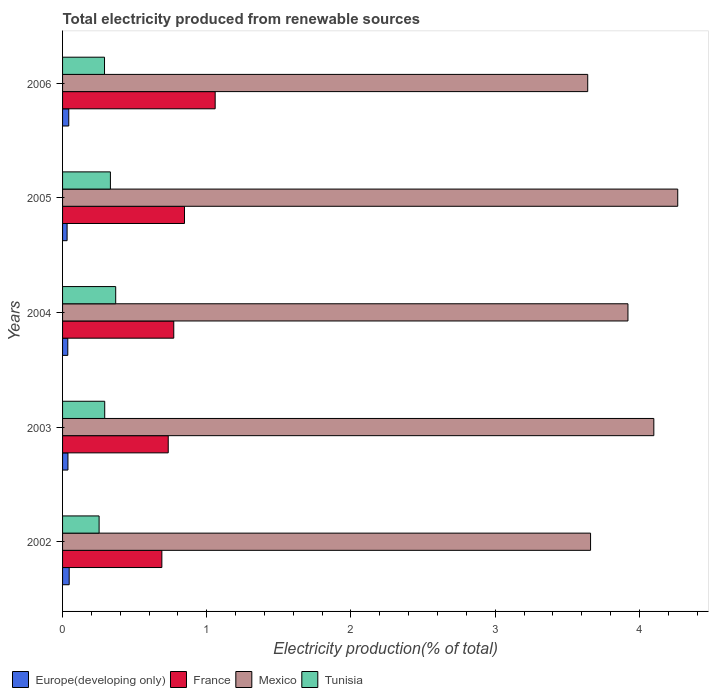What is the label of the 5th group of bars from the top?
Offer a terse response. 2002. What is the total electricity produced in Tunisia in 2002?
Offer a very short reply. 0.25. Across all years, what is the maximum total electricity produced in Europe(developing only)?
Your response must be concise. 0.05. Across all years, what is the minimum total electricity produced in France?
Make the answer very short. 0.69. In which year was the total electricity produced in Tunisia maximum?
Give a very brief answer. 2004. What is the total total electricity produced in France in the graph?
Offer a terse response. 4.1. What is the difference between the total electricity produced in France in 2004 and that in 2005?
Provide a succinct answer. -0.07. What is the difference between the total electricity produced in France in 2006 and the total electricity produced in Mexico in 2005?
Provide a succinct answer. -3.21. What is the average total electricity produced in Mexico per year?
Ensure brevity in your answer.  3.92. In the year 2003, what is the difference between the total electricity produced in Tunisia and total electricity produced in France?
Give a very brief answer. -0.44. What is the ratio of the total electricity produced in Tunisia in 2003 to that in 2004?
Offer a very short reply. 0.79. Is the total electricity produced in Tunisia in 2002 less than that in 2004?
Offer a terse response. Yes. What is the difference between the highest and the second highest total electricity produced in Mexico?
Provide a short and direct response. 0.17. What is the difference between the highest and the lowest total electricity produced in Tunisia?
Provide a succinct answer. 0.12. Is it the case that in every year, the sum of the total electricity produced in Mexico and total electricity produced in France is greater than the sum of total electricity produced in Europe(developing only) and total electricity produced in Tunisia?
Your answer should be compact. Yes. Is it the case that in every year, the sum of the total electricity produced in Tunisia and total electricity produced in Europe(developing only) is greater than the total electricity produced in Mexico?
Give a very brief answer. No. How many bars are there?
Provide a short and direct response. 20. How many years are there in the graph?
Keep it short and to the point. 5. Does the graph contain any zero values?
Provide a succinct answer. No. Where does the legend appear in the graph?
Make the answer very short. Bottom left. How are the legend labels stacked?
Provide a short and direct response. Horizontal. What is the title of the graph?
Your answer should be compact. Total electricity produced from renewable sources. What is the Electricity production(% of total) of Europe(developing only) in 2002?
Offer a terse response. 0.05. What is the Electricity production(% of total) in France in 2002?
Your response must be concise. 0.69. What is the Electricity production(% of total) of Mexico in 2002?
Give a very brief answer. 3.66. What is the Electricity production(% of total) in Tunisia in 2002?
Offer a terse response. 0.25. What is the Electricity production(% of total) of Europe(developing only) in 2003?
Ensure brevity in your answer.  0.04. What is the Electricity production(% of total) of France in 2003?
Provide a short and direct response. 0.73. What is the Electricity production(% of total) in Mexico in 2003?
Offer a very short reply. 4.1. What is the Electricity production(% of total) in Tunisia in 2003?
Offer a terse response. 0.29. What is the Electricity production(% of total) of Europe(developing only) in 2004?
Make the answer very short. 0.04. What is the Electricity production(% of total) in France in 2004?
Provide a short and direct response. 0.77. What is the Electricity production(% of total) of Mexico in 2004?
Your answer should be compact. 3.92. What is the Electricity production(% of total) in Tunisia in 2004?
Ensure brevity in your answer.  0.37. What is the Electricity production(% of total) of Europe(developing only) in 2005?
Offer a very short reply. 0.03. What is the Electricity production(% of total) in France in 2005?
Keep it short and to the point. 0.85. What is the Electricity production(% of total) of Mexico in 2005?
Provide a succinct answer. 4.27. What is the Electricity production(% of total) of Tunisia in 2005?
Give a very brief answer. 0.33. What is the Electricity production(% of total) in Europe(developing only) in 2006?
Provide a short and direct response. 0.04. What is the Electricity production(% of total) in France in 2006?
Your response must be concise. 1.06. What is the Electricity production(% of total) in Mexico in 2006?
Make the answer very short. 3.64. What is the Electricity production(% of total) of Tunisia in 2006?
Your answer should be very brief. 0.29. Across all years, what is the maximum Electricity production(% of total) in Europe(developing only)?
Your answer should be very brief. 0.05. Across all years, what is the maximum Electricity production(% of total) of France?
Offer a very short reply. 1.06. Across all years, what is the maximum Electricity production(% of total) in Mexico?
Provide a succinct answer. 4.27. Across all years, what is the maximum Electricity production(% of total) of Tunisia?
Give a very brief answer. 0.37. Across all years, what is the minimum Electricity production(% of total) of Europe(developing only)?
Offer a very short reply. 0.03. Across all years, what is the minimum Electricity production(% of total) in France?
Give a very brief answer. 0.69. Across all years, what is the minimum Electricity production(% of total) of Mexico?
Ensure brevity in your answer.  3.64. Across all years, what is the minimum Electricity production(% of total) in Tunisia?
Your response must be concise. 0.25. What is the total Electricity production(% of total) in Europe(developing only) in the graph?
Give a very brief answer. 0.19. What is the total Electricity production(% of total) in France in the graph?
Your answer should be very brief. 4.1. What is the total Electricity production(% of total) of Mexico in the graph?
Your answer should be very brief. 19.59. What is the total Electricity production(% of total) in Tunisia in the graph?
Make the answer very short. 1.54. What is the difference between the Electricity production(% of total) in Europe(developing only) in 2002 and that in 2003?
Offer a terse response. 0.01. What is the difference between the Electricity production(% of total) of France in 2002 and that in 2003?
Ensure brevity in your answer.  -0.04. What is the difference between the Electricity production(% of total) in Mexico in 2002 and that in 2003?
Provide a short and direct response. -0.44. What is the difference between the Electricity production(% of total) of Tunisia in 2002 and that in 2003?
Give a very brief answer. -0.04. What is the difference between the Electricity production(% of total) in Europe(developing only) in 2002 and that in 2004?
Your answer should be compact. 0.01. What is the difference between the Electricity production(% of total) of France in 2002 and that in 2004?
Provide a short and direct response. -0.08. What is the difference between the Electricity production(% of total) in Mexico in 2002 and that in 2004?
Your answer should be very brief. -0.26. What is the difference between the Electricity production(% of total) of Tunisia in 2002 and that in 2004?
Provide a succinct answer. -0.12. What is the difference between the Electricity production(% of total) of Europe(developing only) in 2002 and that in 2005?
Your answer should be compact. 0.01. What is the difference between the Electricity production(% of total) of France in 2002 and that in 2005?
Your answer should be compact. -0.16. What is the difference between the Electricity production(% of total) of Mexico in 2002 and that in 2005?
Provide a short and direct response. -0.6. What is the difference between the Electricity production(% of total) in Tunisia in 2002 and that in 2005?
Make the answer very short. -0.08. What is the difference between the Electricity production(% of total) of Europe(developing only) in 2002 and that in 2006?
Offer a terse response. 0. What is the difference between the Electricity production(% of total) of France in 2002 and that in 2006?
Offer a terse response. -0.37. What is the difference between the Electricity production(% of total) of Mexico in 2002 and that in 2006?
Make the answer very short. 0.02. What is the difference between the Electricity production(% of total) of Tunisia in 2002 and that in 2006?
Provide a short and direct response. -0.04. What is the difference between the Electricity production(% of total) of Europe(developing only) in 2003 and that in 2004?
Offer a very short reply. 0. What is the difference between the Electricity production(% of total) of France in 2003 and that in 2004?
Give a very brief answer. -0.04. What is the difference between the Electricity production(% of total) in Mexico in 2003 and that in 2004?
Offer a terse response. 0.18. What is the difference between the Electricity production(% of total) of Tunisia in 2003 and that in 2004?
Give a very brief answer. -0.08. What is the difference between the Electricity production(% of total) of Europe(developing only) in 2003 and that in 2005?
Offer a terse response. 0.01. What is the difference between the Electricity production(% of total) of France in 2003 and that in 2005?
Make the answer very short. -0.11. What is the difference between the Electricity production(% of total) in Mexico in 2003 and that in 2005?
Offer a terse response. -0.17. What is the difference between the Electricity production(% of total) in Tunisia in 2003 and that in 2005?
Provide a succinct answer. -0.04. What is the difference between the Electricity production(% of total) of Europe(developing only) in 2003 and that in 2006?
Provide a succinct answer. -0.01. What is the difference between the Electricity production(% of total) in France in 2003 and that in 2006?
Ensure brevity in your answer.  -0.33. What is the difference between the Electricity production(% of total) of Mexico in 2003 and that in 2006?
Your response must be concise. 0.46. What is the difference between the Electricity production(% of total) of Tunisia in 2003 and that in 2006?
Offer a very short reply. 0. What is the difference between the Electricity production(% of total) of Europe(developing only) in 2004 and that in 2005?
Your answer should be compact. 0. What is the difference between the Electricity production(% of total) in France in 2004 and that in 2005?
Keep it short and to the point. -0.07. What is the difference between the Electricity production(% of total) in Mexico in 2004 and that in 2005?
Provide a succinct answer. -0.35. What is the difference between the Electricity production(% of total) of Tunisia in 2004 and that in 2005?
Provide a short and direct response. 0.04. What is the difference between the Electricity production(% of total) in Europe(developing only) in 2004 and that in 2006?
Provide a short and direct response. -0.01. What is the difference between the Electricity production(% of total) of France in 2004 and that in 2006?
Give a very brief answer. -0.29. What is the difference between the Electricity production(% of total) in Mexico in 2004 and that in 2006?
Keep it short and to the point. 0.28. What is the difference between the Electricity production(% of total) in Tunisia in 2004 and that in 2006?
Offer a very short reply. 0.08. What is the difference between the Electricity production(% of total) in Europe(developing only) in 2005 and that in 2006?
Keep it short and to the point. -0.01. What is the difference between the Electricity production(% of total) of France in 2005 and that in 2006?
Your response must be concise. -0.21. What is the difference between the Electricity production(% of total) of Mexico in 2005 and that in 2006?
Provide a succinct answer. 0.62. What is the difference between the Electricity production(% of total) in Tunisia in 2005 and that in 2006?
Your response must be concise. 0.04. What is the difference between the Electricity production(% of total) of Europe(developing only) in 2002 and the Electricity production(% of total) of France in 2003?
Offer a terse response. -0.69. What is the difference between the Electricity production(% of total) in Europe(developing only) in 2002 and the Electricity production(% of total) in Mexico in 2003?
Your answer should be very brief. -4.05. What is the difference between the Electricity production(% of total) of Europe(developing only) in 2002 and the Electricity production(% of total) of Tunisia in 2003?
Offer a very short reply. -0.25. What is the difference between the Electricity production(% of total) in France in 2002 and the Electricity production(% of total) in Mexico in 2003?
Keep it short and to the point. -3.41. What is the difference between the Electricity production(% of total) in France in 2002 and the Electricity production(% of total) in Tunisia in 2003?
Your answer should be compact. 0.4. What is the difference between the Electricity production(% of total) of Mexico in 2002 and the Electricity production(% of total) of Tunisia in 2003?
Keep it short and to the point. 3.37. What is the difference between the Electricity production(% of total) in Europe(developing only) in 2002 and the Electricity production(% of total) in France in 2004?
Your answer should be compact. -0.73. What is the difference between the Electricity production(% of total) of Europe(developing only) in 2002 and the Electricity production(% of total) of Mexico in 2004?
Ensure brevity in your answer.  -3.87. What is the difference between the Electricity production(% of total) of Europe(developing only) in 2002 and the Electricity production(% of total) of Tunisia in 2004?
Keep it short and to the point. -0.32. What is the difference between the Electricity production(% of total) of France in 2002 and the Electricity production(% of total) of Mexico in 2004?
Make the answer very short. -3.23. What is the difference between the Electricity production(% of total) in France in 2002 and the Electricity production(% of total) in Tunisia in 2004?
Give a very brief answer. 0.32. What is the difference between the Electricity production(% of total) of Mexico in 2002 and the Electricity production(% of total) of Tunisia in 2004?
Provide a succinct answer. 3.29. What is the difference between the Electricity production(% of total) of Europe(developing only) in 2002 and the Electricity production(% of total) of France in 2005?
Your answer should be compact. -0.8. What is the difference between the Electricity production(% of total) of Europe(developing only) in 2002 and the Electricity production(% of total) of Mexico in 2005?
Offer a terse response. -4.22. What is the difference between the Electricity production(% of total) of Europe(developing only) in 2002 and the Electricity production(% of total) of Tunisia in 2005?
Your answer should be very brief. -0.29. What is the difference between the Electricity production(% of total) in France in 2002 and the Electricity production(% of total) in Mexico in 2005?
Provide a succinct answer. -3.58. What is the difference between the Electricity production(% of total) of France in 2002 and the Electricity production(% of total) of Tunisia in 2005?
Offer a very short reply. 0.36. What is the difference between the Electricity production(% of total) in Mexico in 2002 and the Electricity production(% of total) in Tunisia in 2005?
Provide a short and direct response. 3.33. What is the difference between the Electricity production(% of total) in Europe(developing only) in 2002 and the Electricity production(% of total) in France in 2006?
Provide a short and direct response. -1.01. What is the difference between the Electricity production(% of total) of Europe(developing only) in 2002 and the Electricity production(% of total) of Mexico in 2006?
Provide a succinct answer. -3.6. What is the difference between the Electricity production(% of total) in Europe(developing only) in 2002 and the Electricity production(% of total) in Tunisia in 2006?
Give a very brief answer. -0.24. What is the difference between the Electricity production(% of total) in France in 2002 and the Electricity production(% of total) in Mexico in 2006?
Your answer should be compact. -2.95. What is the difference between the Electricity production(% of total) of France in 2002 and the Electricity production(% of total) of Tunisia in 2006?
Your answer should be compact. 0.4. What is the difference between the Electricity production(% of total) of Mexico in 2002 and the Electricity production(% of total) of Tunisia in 2006?
Provide a short and direct response. 3.37. What is the difference between the Electricity production(% of total) of Europe(developing only) in 2003 and the Electricity production(% of total) of France in 2004?
Ensure brevity in your answer.  -0.73. What is the difference between the Electricity production(% of total) in Europe(developing only) in 2003 and the Electricity production(% of total) in Mexico in 2004?
Offer a terse response. -3.88. What is the difference between the Electricity production(% of total) of Europe(developing only) in 2003 and the Electricity production(% of total) of Tunisia in 2004?
Offer a very short reply. -0.33. What is the difference between the Electricity production(% of total) of France in 2003 and the Electricity production(% of total) of Mexico in 2004?
Your answer should be compact. -3.19. What is the difference between the Electricity production(% of total) of France in 2003 and the Electricity production(% of total) of Tunisia in 2004?
Give a very brief answer. 0.36. What is the difference between the Electricity production(% of total) in Mexico in 2003 and the Electricity production(% of total) in Tunisia in 2004?
Provide a short and direct response. 3.73. What is the difference between the Electricity production(% of total) in Europe(developing only) in 2003 and the Electricity production(% of total) in France in 2005?
Keep it short and to the point. -0.81. What is the difference between the Electricity production(% of total) of Europe(developing only) in 2003 and the Electricity production(% of total) of Mexico in 2005?
Ensure brevity in your answer.  -4.23. What is the difference between the Electricity production(% of total) of Europe(developing only) in 2003 and the Electricity production(% of total) of Tunisia in 2005?
Keep it short and to the point. -0.29. What is the difference between the Electricity production(% of total) of France in 2003 and the Electricity production(% of total) of Mexico in 2005?
Your answer should be very brief. -3.53. What is the difference between the Electricity production(% of total) in France in 2003 and the Electricity production(% of total) in Tunisia in 2005?
Provide a short and direct response. 0.4. What is the difference between the Electricity production(% of total) in Mexico in 2003 and the Electricity production(% of total) in Tunisia in 2005?
Provide a short and direct response. 3.77. What is the difference between the Electricity production(% of total) of Europe(developing only) in 2003 and the Electricity production(% of total) of France in 2006?
Make the answer very short. -1.02. What is the difference between the Electricity production(% of total) in Europe(developing only) in 2003 and the Electricity production(% of total) in Mexico in 2006?
Offer a terse response. -3.6. What is the difference between the Electricity production(% of total) of Europe(developing only) in 2003 and the Electricity production(% of total) of Tunisia in 2006?
Keep it short and to the point. -0.25. What is the difference between the Electricity production(% of total) of France in 2003 and the Electricity production(% of total) of Mexico in 2006?
Offer a very short reply. -2.91. What is the difference between the Electricity production(% of total) in France in 2003 and the Electricity production(% of total) in Tunisia in 2006?
Give a very brief answer. 0.44. What is the difference between the Electricity production(% of total) in Mexico in 2003 and the Electricity production(% of total) in Tunisia in 2006?
Offer a terse response. 3.81. What is the difference between the Electricity production(% of total) of Europe(developing only) in 2004 and the Electricity production(% of total) of France in 2005?
Your answer should be very brief. -0.81. What is the difference between the Electricity production(% of total) of Europe(developing only) in 2004 and the Electricity production(% of total) of Mexico in 2005?
Ensure brevity in your answer.  -4.23. What is the difference between the Electricity production(% of total) of Europe(developing only) in 2004 and the Electricity production(% of total) of Tunisia in 2005?
Your response must be concise. -0.3. What is the difference between the Electricity production(% of total) of France in 2004 and the Electricity production(% of total) of Mexico in 2005?
Keep it short and to the point. -3.49. What is the difference between the Electricity production(% of total) of France in 2004 and the Electricity production(% of total) of Tunisia in 2005?
Provide a short and direct response. 0.44. What is the difference between the Electricity production(% of total) in Mexico in 2004 and the Electricity production(% of total) in Tunisia in 2005?
Provide a succinct answer. 3.59. What is the difference between the Electricity production(% of total) of Europe(developing only) in 2004 and the Electricity production(% of total) of France in 2006?
Give a very brief answer. -1.02. What is the difference between the Electricity production(% of total) of Europe(developing only) in 2004 and the Electricity production(% of total) of Mexico in 2006?
Ensure brevity in your answer.  -3.61. What is the difference between the Electricity production(% of total) in Europe(developing only) in 2004 and the Electricity production(% of total) in Tunisia in 2006?
Offer a terse response. -0.25. What is the difference between the Electricity production(% of total) in France in 2004 and the Electricity production(% of total) in Mexico in 2006?
Make the answer very short. -2.87. What is the difference between the Electricity production(% of total) in France in 2004 and the Electricity production(% of total) in Tunisia in 2006?
Provide a succinct answer. 0.48. What is the difference between the Electricity production(% of total) in Mexico in 2004 and the Electricity production(% of total) in Tunisia in 2006?
Your answer should be compact. 3.63. What is the difference between the Electricity production(% of total) in Europe(developing only) in 2005 and the Electricity production(% of total) in France in 2006?
Make the answer very short. -1.03. What is the difference between the Electricity production(% of total) of Europe(developing only) in 2005 and the Electricity production(% of total) of Mexico in 2006?
Ensure brevity in your answer.  -3.61. What is the difference between the Electricity production(% of total) of Europe(developing only) in 2005 and the Electricity production(% of total) of Tunisia in 2006?
Provide a succinct answer. -0.26. What is the difference between the Electricity production(% of total) in France in 2005 and the Electricity production(% of total) in Mexico in 2006?
Your response must be concise. -2.8. What is the difference between the Electricity production(% of total) in France in 2005 and the Electricity production(% of total) in Tunisia in 2006?
Provide a short and direct response. 0.55. What is the difference between the Electricity production(% of total) of Mexico in 2005 and the Electricity production(% of total) of Tunisia in 2006?
Your response must be concise. 3.97. What is the average Electricity production(% of total) in Europe(developing only) per year?
Make the answer very short. 0.04. What is the average Electricity production(% of total) in France per year?
Provide a short and direct response. 0.82. What is the average Electricity production(% of total) of Mexico per year?
Your response must be concise. 3.92. What is the average Electricity production(% of total) in Tunisia per year?
Make the answer very short. 0.31. In the year 2002, what is the difference between the Electricity production(% of total) of Europe(developing only) and Electricity production(% of total) of France?
Give a very brief answer. -0.64. In the year 2002, what is the difference between the Electricity production(% of total) of Europe(developing only) and Electricity production(% of total) of Mexico?
Provide a short and direct response. -3.62. In the year 2002, what is the difference between the Electricity production(% of total) in Europe(developing only) and Electricity production(% of total) in Tunisia?
Your answer should be very brief. -0.21. In the year 2002, what is the difference between the Electricity production(% of total) in France and Electricity production(% of total) in Mexico?
Offer a very short reply. -2.97. In the year 2002, what is the difference between the Electricity production(% of total) in France and Electricity production(% of total) in Tunisia?
Make the answer very short. 0.44. In the year 2002, what is the difference between the Electricity production(% of total) of Mexico and Electricity production(% of total) of Tunisia?
Offer a very short reply. 3.41. In the year 2003, what is the difference between the Electricity production(% of total) in Europe(developing only) and Electricity production(% of total) in France?
Your answer should be compact. -0.7. In the year 2003, what is the difference between the Electricity production(% of total) of Europe(developing only) and Electricity production(% of total) of Mexico?
Keep it short and to the point. -4.06. In the year 2003, what is the difference between the Electricity production(% of total) of Europe(developing only) and Electricity production(% of total) of Tunisia?
Offer a very short reply. -0.25. In the year 2003, what is the difference between the Electricity production(% of total) in France and Electricity production(% of total) in Mexico?
Provide a succinct answer. -3.37. In the year 2003, what is the difference between the Electricity production(% of total) in France and Electricity production(% of total) in Tunisia?
Ensure brevity in your answer.  0.44. In the year 2003, what is the difference between the Electricity production(% of total) of Mexico and Electricity production(% of total) of Tunisia?
Your response must be concise. 3.81. In the year 2004, what is the difference between the Electricity production(% of total) in Europe(developing only) and Electricity production(% of total) in France?
Offer a terse response. -0.73. In the year 2004, what is the difference between the Electricity production(% of total) of Europe(developing only) and Electricity production(% of total) of Mexico?
Give a very brief answer. -3.88. In the year 2004, what is the difference between the Electricity production(% of total) in Europe(developing only) and Electricity production(% of total) in Tunisia?
Your response must be concise. -0.33. In the year 2004, what is the difference between the Electricity production(% of total) of France and Electricity production(% of total) of Mexico?
Your answer should be compact. -3.15. In the year 2004, what is the difference between the Electricity production(% of total) in France and Electricity production(% of total) in Tunisia?
Your answer should be compact. 0.4. In the year 2004, what is the difference between the Electricity production(% of total) in Mexico and Electricity production(% of total) in Tunisia?
Give a very brief answer. 3.55. In the year 2005, what is the difference between the Electricity production(% of total) in Europe(developing only) and Electricity production(% of total) in France?
Provide a short and direct response. -0.81. In the year 2005, what is the difference between the Electricity production(% of total) in Europe(developing only) and Electricity production(% of total) in Mexico?
Your answer should be very brief. -4.23. In the year 2005, what is the difference between the Electricity production(% of total) in Europe(developing only) and Electricity production(% of total) in Tunisia?
Give a very brief answer. -0.3. In the year 2005, what is the difference between the Electricity production(% of total) in France and Electricity production(% of total) in Mexico?
Provide a succinct answer. -3.42. In the year 2005, what is the difference between the Electricity production(% of total) in France and Electricity production(% of total) in Tunisia?
Provide a short and direct response. 0.51. In the year 2005, what is the difference between the Electricity production(% of total) of Mexico and Electricity production(% of total) of Tunisia?
Make the answer very short. 3.93. In the year 2006, what is the difference between the Electricity production(% of total) in Europe(developing only) and Electricity production(% of total) in France?
Ensure brevity in your answer.  -1.02. In the year 2006, what is the difference between the Electricity production(% of total) in Europe(developing only) and Electricity production(% of total) in Mexico?
Your response must be concise. -3.6. In the year 2006, what is the difference between the Electricity production(% of total) of Europe(developing only) and Electricity production(% of total) of Tunisia?
Provide a succinct answer. -0.25. In the year 2006, what is the difference between the Electricity production(% of total) of France and Electricity production(% of total) of Mexico?
Your response must be concise. -2.58. In the year 2006, what is the difference between the Electricity production(% of total) of France and Electricity production(% of total) of Tunisia?
Keep it short and to the point. 0.77. In the year 2006, what is the difference between the Electricity production(% of total) in Mexico and Electricity production(% of total) in Tunisia?
Offer a very short reply. 3.35. What is the ratio of the Electricity production(% of total) in Europe(developing only) in 2002 to that in 2003?
Offer a very short reply. 1.23. What is the ratio of the Electricity production(% of total) in France in 2002 to that in 2003?
Keep it short and to the point. 0.94. What is the ratio of the Electricity production(% of total) of Mexico in 2002 to that in 2003?
Keep it short and to the point. 0.89. What is the ratio of the Electricity production(% of total) of Tunisia in 2002 to that in 2003?
Offer a very short reply. 0.87. What is the ratio of the Electricity production(% of total) in Europe(developing only) in 2002 to that in 2004?
Make the answer very short. 1.26. What is the ratio of the Electricity production(% of total) in France in 2002 to that in 2004?
Keep it short and to the point. 0.89. What is the ratio of the Electricity production(% of total) of Mexico in 2002 to that in 2004?
Your answer should be very brief. 0.93. What is the ratio of the Electricity production(% of total) of Tunisia in 2002 to that in 2004?
Your answer should be compact. 0.69. What is the ratio of the Electricity production(% of total) of Europe(developing only) in 2002 to that in 2005?
Offer a very short reply. 1.46. What is the ratio of the Electricity production(% of total) of France in 2002 to that in 2005?
Make the answer very short. 0.81. What is the ratio of the Electricity production(% of total) in Mexico in 2002 to that in 2005?
Provide a short and direct response. 0.86. What is the ratio of the Electricity production(% of total) of Tunisia in 2002 to that in 2005?
Provide a short and direct response. 0.76. What is the ratio of the Electricity production(% of total) in Europe(developing only) in 2002 to that in 2006?
Your answer should be compact. 1.07. What is the ratio of the Electricity production(% of total) of France in 2002 to that in 2006?
Offer a very short reply. 0.65. What is the ratio of the Electricity production(% of total) of Mexico in 2002 to that in 2006?
Offer a terse response. 1.01. What is the ratio of the Electricity production(% of total) in Tunisia in 2002 to that in 2006?
Make the answer very short. 0.87. What is the ratio of the Electricity production(% of total) of Europe(developing only) in 2003 to that in 2004?
Keep it short and to the point. 1.03. What is the ratio of the Electricity production(% of total) of France in 2003 to that in 2004?
Provide a succinct answer. 0.95. What is the ratio of the Electricity production(% of total) of Mexico in 2003 to that in 2004?
Your answer should be very brief. 1.05. What is the ratio of the Electricity production(% of total) in Tunisia in 2003 to that in 2004?
Give a very brief answer. 0.79. What is the ratio of the Electricity production(% of total) in Europe(developing only) in 2003 to that in 2005?
Your answer should be compact. 1.19. What is the ratio of the Electricity production(% of total) of France in 2003 to that in 2005?
Give a very brief answer. 0.87. What is the ratio of the Electricity production(% of total) in Mexico in 2003 to that in 2005?
Offer a terse response. 0.96. What is the ratio of the Electricity production(% of total) of Tunisia in 2003 to that in 2005?
Make the answer very short. 0.88. What is the ratio of the Electricity production(% of total) in Europe(developing only) in 2003 to that in 2006?
Your answer should be compact. 0.87. What is the ratio of the Electricity production(% of total) of France in 2003 to that in 2006?
Offer a very short reply. 0.69. What is the ratio of the Electricity production(% of total) in Mexico in 2003 to that in 2006?
Offer a very short reply. 1.13. What is the ratio of the Electricity production(% of total) in Tunisia in 2003 to that in 2006?
Your answer should be very brief. 1. What is the ratio of the Electricity production(% of total) in Europe(developing only) in 2004 to that in 2005?
Provide a short and direct response. 1.16. What is the ratio of the Electricity production(% of total) of France in 2004 to that in 2005?
Make the answer very short. 0.91. What is the ratio of the Electricity production(% of total) of Mexico in 2004 to that in 2005?
Provide a succinct answer. 0.92. What is the ratio of the Electricity production(% of total) of Tunisia in 2004 to that in 2005?
Offer a very short reply. 1.11. What is the ratio of the Electricity production(% of total) in Europe(developing only) in 2004 to that in 2006?
Give a very brief answer. 0.84. What is the ratio of the Electricity production(% of total) in France in 2004 to that in 2006?
Make the answer very short. 0.73. What is the ratio of the Electricity production(% of total) in Mexico in 2004 to that in 2006?
Keep it short and to the point. 1.08. What is the ratio of the Electricity production(% of total) of Tunisia in 2004 to that in 2006?
Keep it short and to the point. 1.27. What is the ratio of the Electricity production(% of total) in Europe(developing only) in 2005 to that in 2006?
Provide a succinct answer. 0.73. What is the ratio of the Electricity production(% of total) of France in 2005 to that in 2006?
Your answer should be compact. 0.8. What is the ratio of the Electricity production(% of total) of Mexico in 2005 to that in 2006?
Offer a very short reply. 1.17. What is the ratio of the Electricity production(% of total) of Tunisia in 2005 to that in 2006?
Provide a short and direct response. 1.14. What is the difference between the highest and the second highest Electricity production(% of total) of Europe(developing only)?
Your answer should be compact. 0. What is the difference between the highest and the second highest Electricity production(% of total) of France?
Your response must be concise. 0.21. What is the difference between the highest and the second highest Electricity production(% of total) in Mexico?
Offer a very short reply. 0.17. What is the difference between the highest and the second highest Electricity production(% of total) of Tunisia?
Make the answer very short. 0.04. What is the difference between the highest and the lowest Electricity production(% of total) of Europe(developing only)?
Provide a succinct answer. 0.01. What is the difference between the highest and the lowest Electricity production(% of total) in France?
Your answer should be very brief. 0.37. What is the difference between the highest and the lowest Electricity production(% of total) of Mexico?
Ensure brevity in your answer.  0.62. What is the difference between the highest and the lowest Electricity production(% of total) of Tunisia?
Provide a succinct answer. 0.12. 